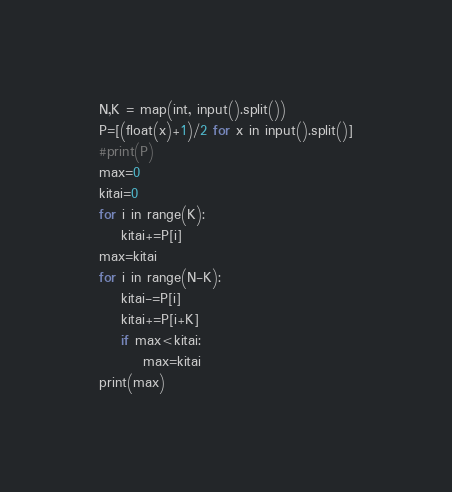Convert code to text. <code><loc_0><loc_0><loc_500><loc_500><_Python_>N,K = map(int, input().split())
P=[(float(x)+1)/2 for x in input().split()]
#print(P)
max=0
kitai=0
for i in range(K):
    kitai+=P[i]
max=kitai
for i in range(N-K):
    kitai-=P[i]
    kitai+=P[i+K]
    if max<kitai:
        max=kitai
print(max)
</code> 